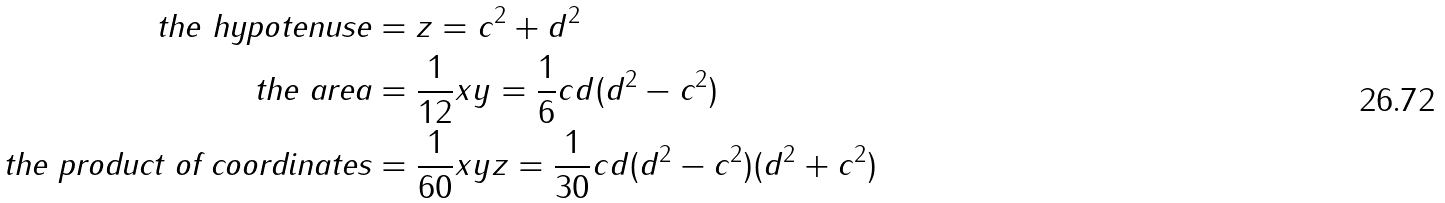<formula> <loc_0><loc_0><loc_500><loc_500>\text {the hypotenuse} & = z = c ^ { 2 } + d ^ { 2 } \\ \text {the area} & = \frac { 1 } { 1 2 } x y = \frac { 1 } { 6 } c d ( d ^ { 2 } - c ^ { 2 } ) \\ \text {the product of coordinates} & = \frac { 1 } { 6 0 } x y z = \frac { 1 } { 3 0 } c d ( d ^ { 2 } - c ^ { 2 } ) ( d ^ { 2 } + c ^ { 2 } ) \\</formula> 